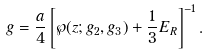<formula> <loc_0><loc_0><loc_500><loc_500>g = \frac { a } { 4 } \left [ \wp ( z ; g _ { 2 } , g _ { 3 } ) + \frac { 1 } { 3 } E _ { R } \right ] ^ { - 1 } .</formula> 